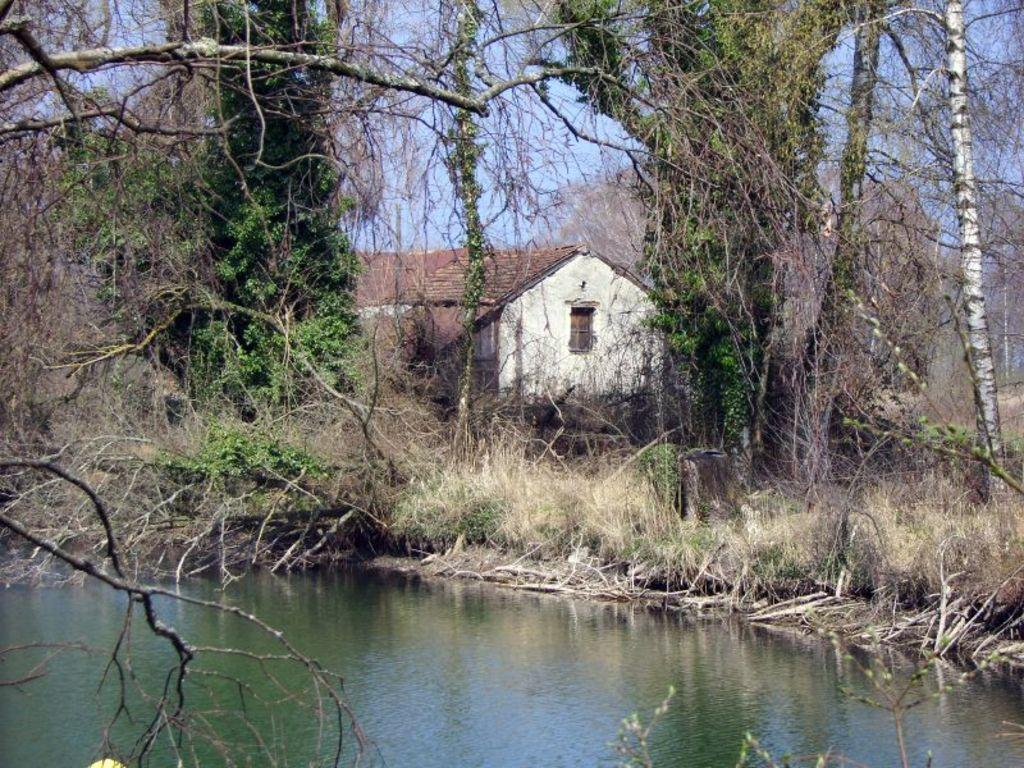What type of structure is present in the image? There is a house in the image. What type of vegetation can be seen in the image? There are trees and grass in the image. What natural element is visible in the image? There is water visible in the image. What color is the sky in the background of the image? The sky is blue in the background of the image. Where is the basketball located in the image? There is no basketball present in the image. What type of underwear is hanging on the clothesline in the image? There is no underwear or clothesline present in the image. 